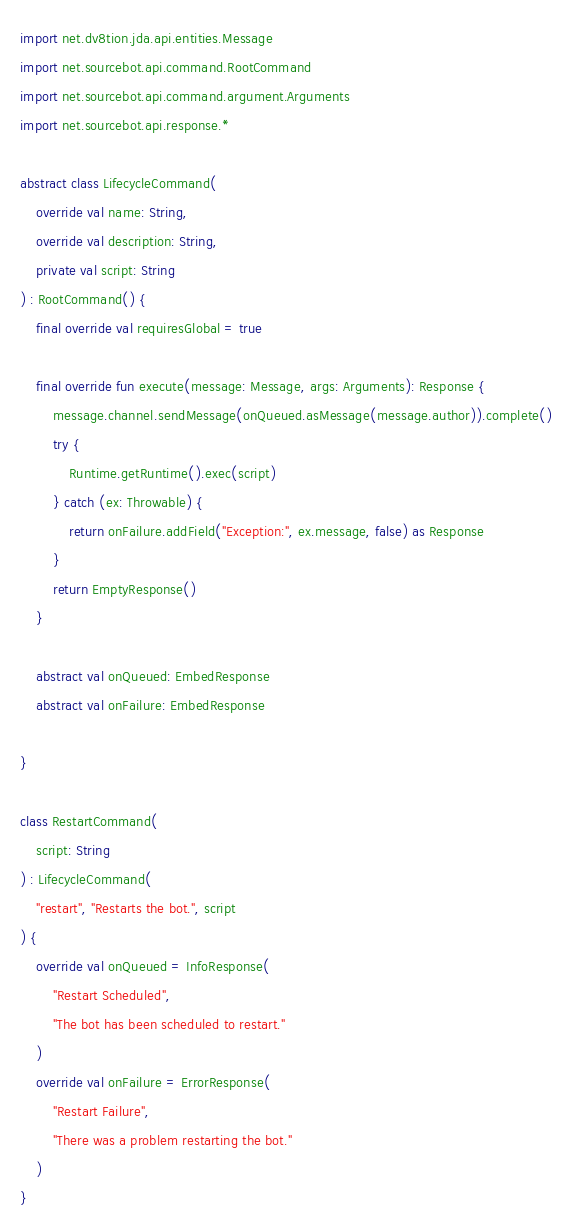Convert code to text. <code><loc_0><loc_0><loc_500><loc_500><_Kotlin_>
import net.dv8tion.jda.api.entities.Message
import net.sourcebot.api.command.RootCommand
import net.sourcebot.api.command.argument.Arguments
import net.sourcebot.api.response.*

abstract class LifecycleCommand(
    override val name: String,
    override val description: String,
    private val script: String
) : RootCommand() {
    final override val requiresGlobal = true

    final override fun execute(message: Message, args: Arguments): Response {
        message.channel.sendMessage(onQueued.asMessage(message.author)).complete()
        try {
            Runtime.getRuntime().exec(script)
        } catch (ex: Throwable) {
            return onFailure.addField("Exception:", ex.message, false) as Response
        }
        return EmptyResponse()
    }

    abstract val onQueued: EmbedResponse
    abstract val onFailure: EmbedResponse

}

class RestartCommand(
    script: String
) : LifecycleCommand(
    "restart", "Restarts the bot.", script
) {
    override val onQueued = InfoResponse(
        "Restart Scheduled",
        "The bot has been scheduled to restart."
    )
    override val onFailure = ErrorResponse(
        "Restart Failure",
        "There was a problem restarting the bot."
    )
}</code> 